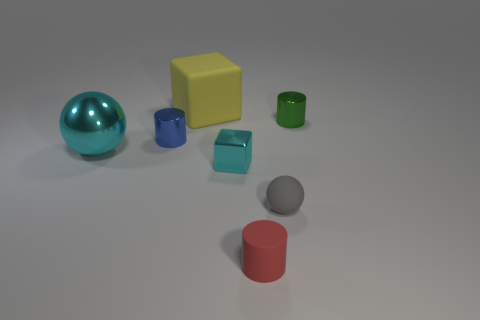Are there any gray rubber objects that have the same shape as the green thing?
Offer a very short reply. No. Are there fewer tiny matte objects than tiny gray spheres?
Your answer should be very brief. No. What color is the tiny shiny object on the left side of the large yellow block?
Provide a succinct answer. Blue. What is the shape of the cyan metal object that is right of the cyan metallic ball on the left side of the red rubber thing?
Offer a terse response. Cube. Is the material of the small cyan block the same as the sphere to the right of the big yellow block?
Ensure brevity in your answer.  No. What shape is the small object that is the same color as the shiny ball?
Give a very brief answer. Cube. How many brown blocks are the same size as the cyan cube?
Make the answer very short. 0. Is the number of tiny red things on the left side of the large cyan ball less than the number of red metallic things?
Provide a succinct answer. No. There is a small gray sphere; how many small metallic cylinders are on the left side of it?
Your response must be concise. 1. What is the size of the rubber object that is to the right of the cylinder that is in front of the small shiny block in front of the big cyan object?
Offer a terse response. Small. 